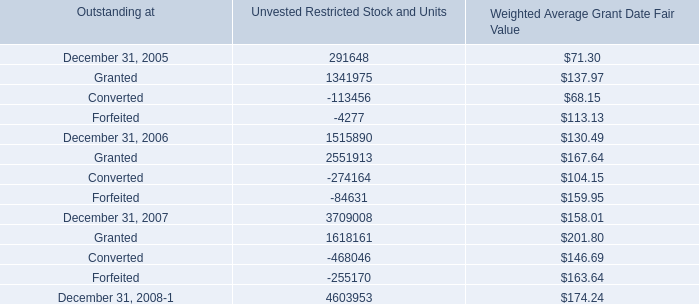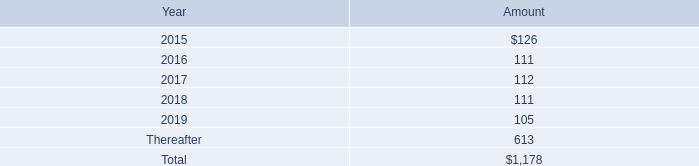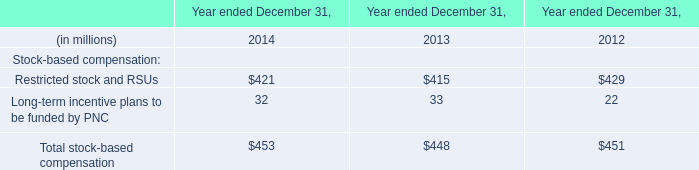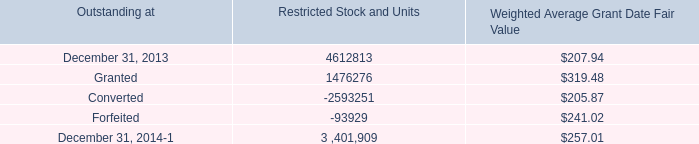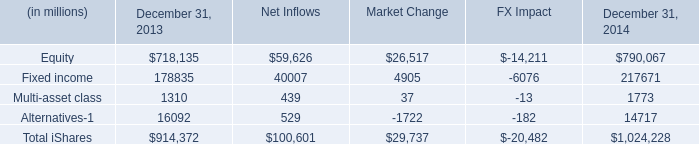What's the sum of Converted of Restricted Stock and Units, and December 31, 2007 of Unvested Restricted Stock and Units ? 
Computations: (2593251.0 + 3709008.0)
Answer: 6302259.0. 